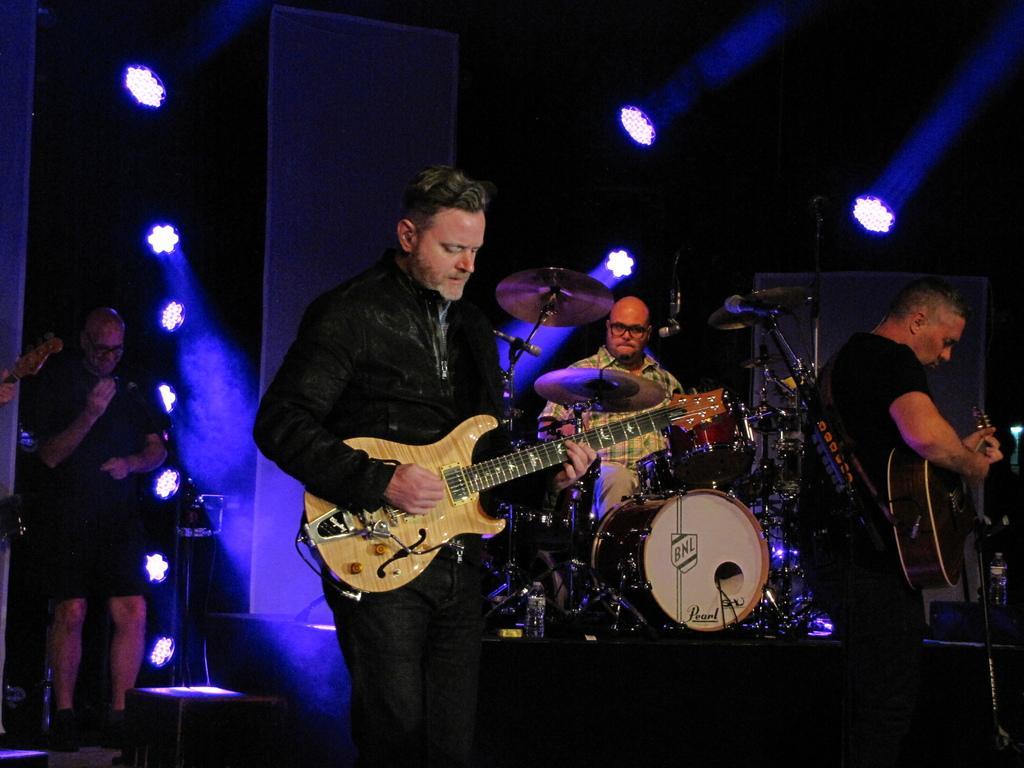How would you summarize this image in a sentence or two? this is a image of inside of room. and three persons playing a music and there are holding a guitar and right side a person stands and there are some lights on left side. 